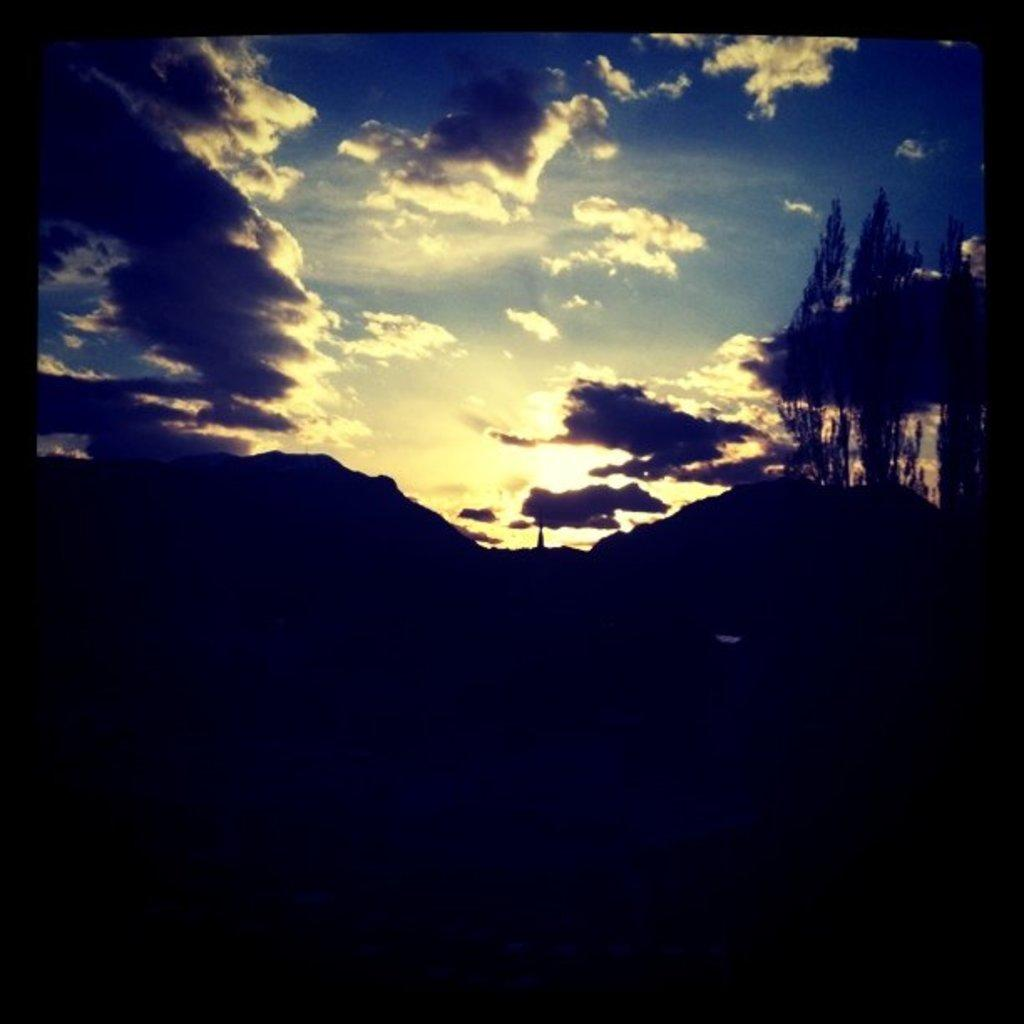What is the setting of the image? The image has an outside view. What can be seen in the foreground of the image? There are hills in the foreground of the image. What is visible in the background of the image? There is a sky visible in the background of the image. What shape is the family in the image? There is no family present in the image, so it is not possible to determine the shape of a family. 